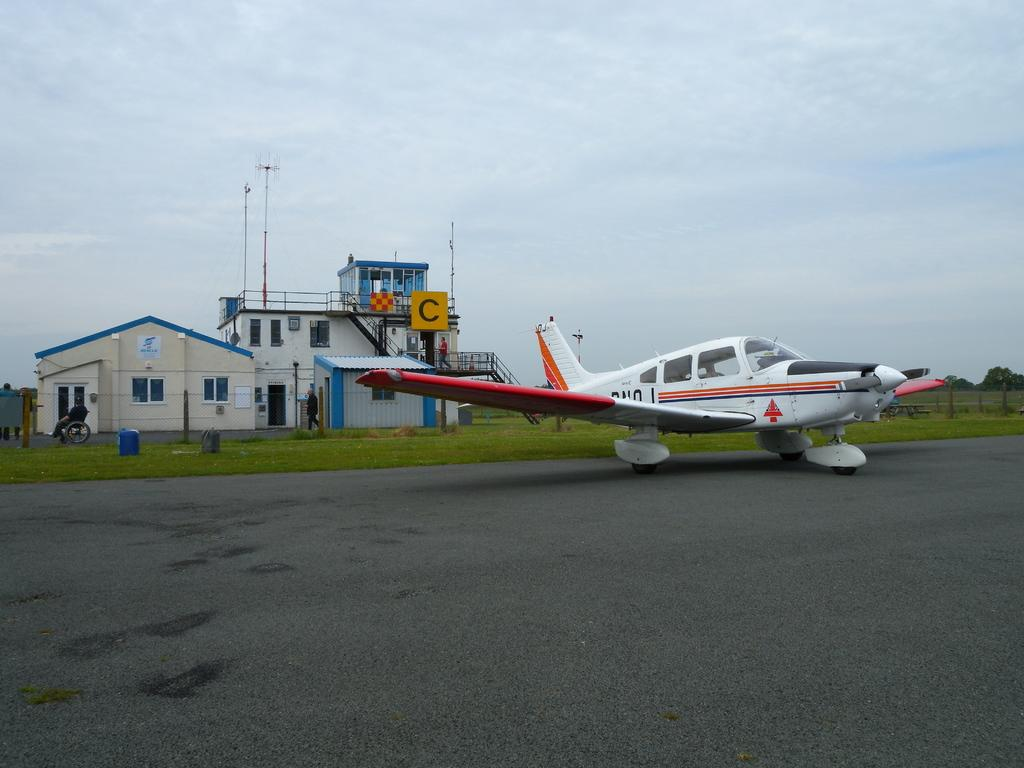What is the main subject in the center of the image? There is an aeroplane on the runway in the center of the image. What can be seen in the background of the image? There is grass, fencing, persons, a shed, a building, trees, and the sky visible in the background of the image. What is the condition of the sky in the image? The sky is visible in the background of the image, and there are clouds present. What type of lettuce is being used to repair the aeroplane in the image? There is no lettuce present in the image, and it is not being used to repair the aeroplane. What color are the trousers worn by the persons in the background of the image? The provided facts do not mention the color of the trousers worn by the persons in the background of the image. --- 